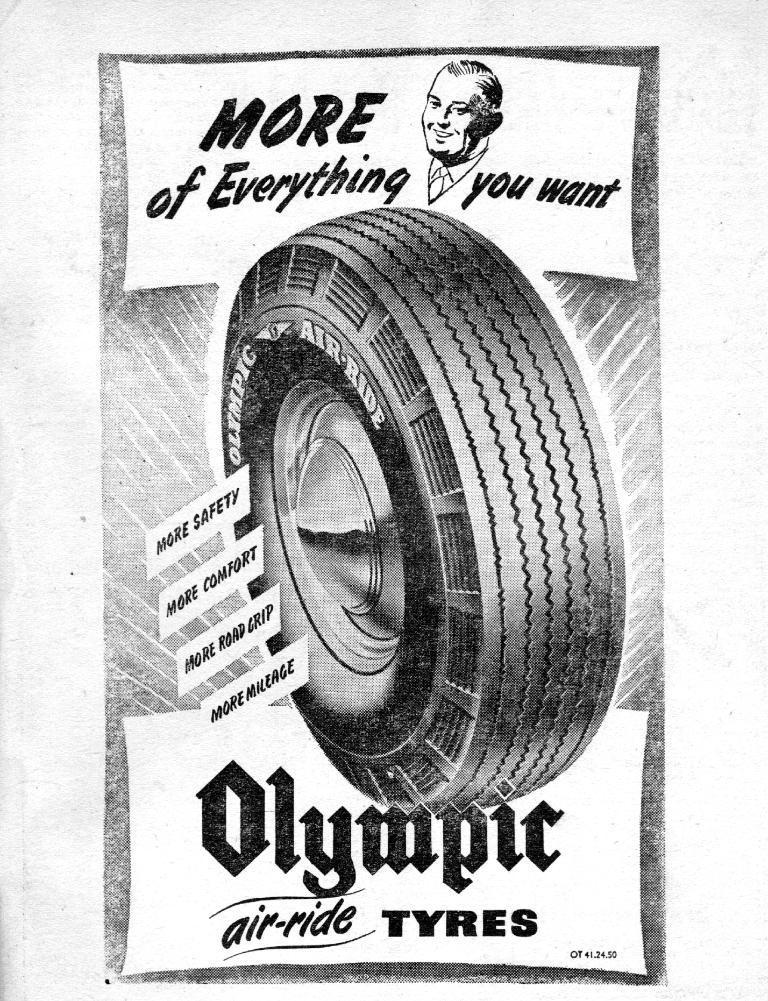Describe this image in one or two sentences. In this image I can see a tyre and a text. On the top I can see a person's photo. 